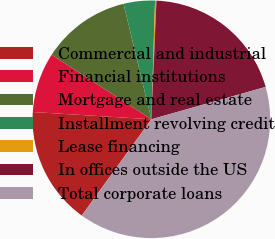<chart> <loc_0><loc_0><loc_500><loc_500><pie_chart><fcel>Commercial and industrial<fcel>Financial institutions<fcel>Mortgage and real estate<fcel>Installment revolving credit<fcel>Lease financing<fcel>In offices outside the US<fcel>Total corporate loans<nl><fcel>16.01%<fcel>8.17%<fcel>12.09%<fcel>4.26%<fcel>0.19%<fcel>19.92%<fcel>39.36%<nl></chart> 